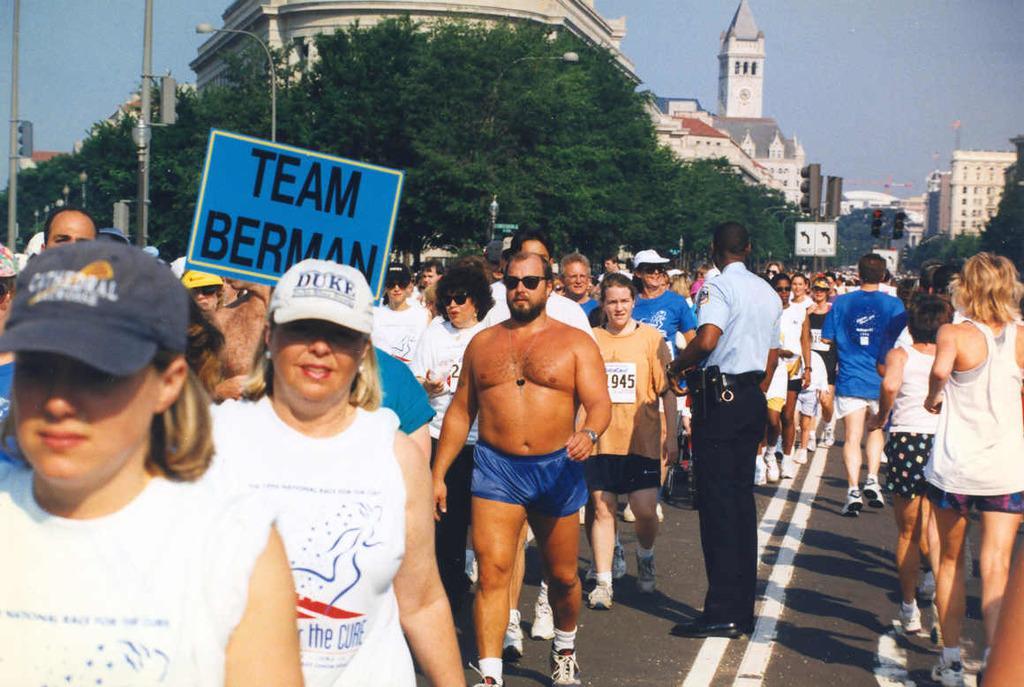Can you describe this image briefly? In this picture we can see some people are walking, some people are running and a person is standing on the road. A person is holding a board and behind the people there are poles with boards, lights and traffic signals. Behind the poles there are trees, buildings and the sky. 